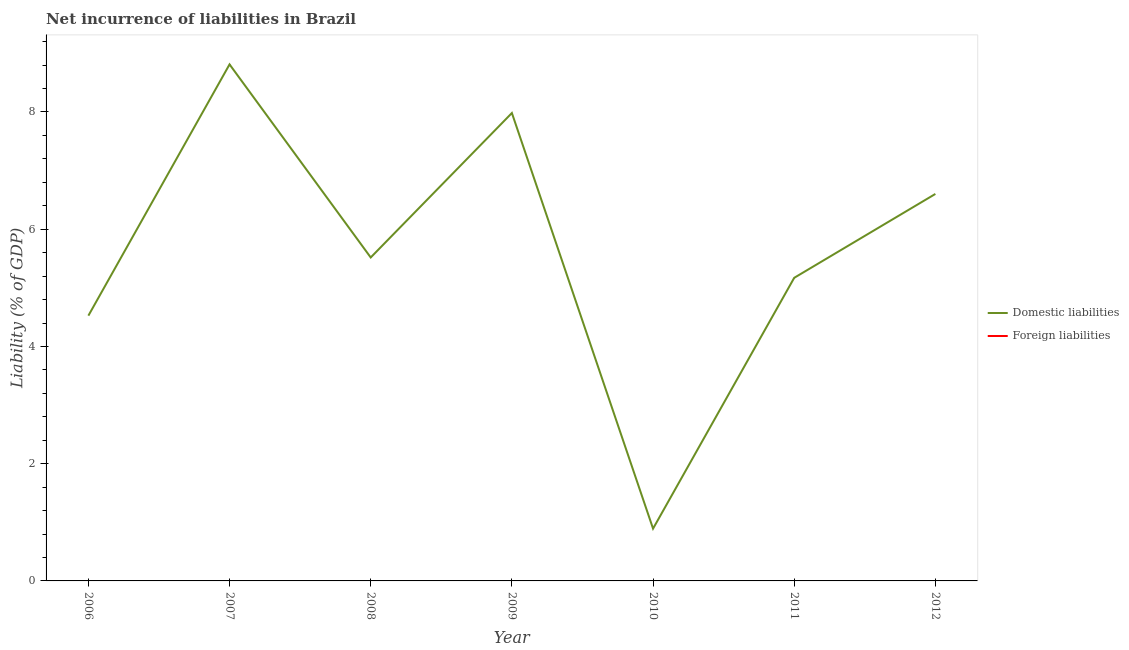How many different coloured lines are there?
Give a very brief answer. 1. Does the line corresponding to incurrence of foreign liabilities intersect with the line corresponding to incurrence of domestic liabilities?
Make the answer very short. No. Is the number of lines equal to the number of legend labels?
Ensure brevity in your answer.  No. Across all years, what is the maximum incurrence of domestic liabilities?
Provide a short and direct response. 8.81. Across all years, what is the minimum incurrence of domestic liabilities?
Offer a very short reply. 0.89. In which year was the incurrence of domestic liabilities maximum?
Give a very brief answer. 2007. What is the total incurrence of foreign liabilities in the graph?
Keep it short and to the point. 0. What is the difference between the incurrence of domestic liabilities in 2010 and that in 2012?
Keep it short and to the point. -5.71. What is the difference between the incurrence of domestic liabilities in 2011 and the incurrence of foreign liabilities in 2012?
Your answer should be very brief. 5.17. What is the ratio of the incurrence of domestic liabilities in 2009 to that in 2012?
Your answer should be very brief. 1.21. Is the incurrence of domestic liabilities in 2007 less than that in 2008?
Offer a terse response. No. What is the difference between the highest and the second highest incurrence of domestic liabilities?
Give a very brief answer. 0.83. What is the difference between the highest and the lowest incurrence of domestic liabilities?
Provide a succinct answer. 7.92. Does the incurrence of foreign liabilities monotonically increase over the years?
Keep it short and to the point. No. How many years are there in the graph?
Make the answer very short. 7. Are the values on the major ticks of Y-axis written in scientific E-notation?
Your response must be concise. No. Does the graph contain any zero values?
Keep it short and to the point. Yes. Does the graph contain grids?
Offer a terse response. No. How many legend labels are there?
Provide a succinct answer. 2. What is the title of the graph?
Give a very brief answer. Net incurrence of liabilities in Brazil. Does "Resident" appear as one of the legend labels in the graph?
Make the answer very short. No. What is the label or title of the X-axis?
Ensure brevity in your answer.  Year. What is the label or title of the Y-axis?
Provide a short and direct response. Liability (% of GDP). What is the Liability (% of GDP) of Domestic liabilities in 2006?
Give a very brief answer. 4.53. What is the Liability (% of GDP) of Domestic liabilities in 2007?
Your answer should be compact. 8.81. What is the Liability (% of GDP) of Foreign liabilities in 2007?
Ensure brevity in your answer.  0. What is the Liability (% of GDP) of Domestic liabilities in 2008?
Keep it short and to the point. 5.52. What is the Liability (% of GDP) in Domestic liabilities in 2009?
Provide a short and direct response. 7.98. What is the Liability (% of GDP) in Foreign liabilities in 2009?
Offer a terse response. 0. What is the Liability (% of GDP) of Domestic liabilities in 2010?
Your answer should be compact. 0.89. What is the Liability (% of GDP) in Foreign liabilities in 2010?
Keep it short and to the point. 0. What is the Liability (% of GDP) of Domestic liabilities in 2011?
Give a very brief answer. 5.17. What is the Liability (% of GDP) of Foreign liabilities in 2011?
Keep it short and to the point. 0. What is the Liability (% of GDP) of Domestic liabilities in 2012?
Ensure brevity in your answer.  6.6. What is the Liability (% of GDP) in Foreign liabilities in 2012?
Provide a succinct answer. 0. Across all years, what is the maximum Liability (% of GDP) in Domestic liabilities?
Your response must be concise. 8.81. Across all years, what is the minimum Liability (% of GDP) of Domestic liabilities?
Ensure brevity in your answer.  0.89. What is the total Liability (% of GDP) in Domestic liabilities in the graph?
Provide a succinct answer. 39.5. What is the difference between the Liability (% of GDP) of Domestic liabilities in 2006 and that in 2007?
Offer a very short reply. -4.29. What is the difference between the Liability (% of GDP) of Domestic liabilities in 2006 and that in 2008?
Provide a short and direct response. -0.99. What is the difference between the Liability (% of GDP) in Domestic liabilities in 2006 and that in 2009?
Your answer should be very brief. -3.46. What is the difference between the Liability (% of GDP) of Domestic liabilities in 2006 and that in 2010?
Provide a succinct answer. 3.63. What is the difference between the Liability (% of GDP) in Domestic liabilities in 2006 and that in 2011?
Give a very brief answer. -0.65. What is the difference between the Liability (% of GDP) in Domestic liabilities in 2006 and that in 2012?
Keep it short and to the point. -2.08. What is the difference between the Liability (% of GDP) in Domestic liabilities in 2007 and that in 2008?
Your response must be concise. 3.29. What is the difference between the Liability (% of GDP) of Domestic liabilities in 2007 and that in 2009?
Your answer should be compact. 0.83. What is the difference between the Liability (% of GDP) in Domestic liabilities in 2007 and that in 2010?
Your answer should be very brief. 7.92. What is the difference between the Liability (% of GDP) in Domestic liabilities in 2007 and that in 2011?
Give a very brief answer. 3.64. What is the difference between the Liability (% of GDP) of Domestic liabilities in 2007 and that in 2012?
Offer a terse response. 2.21. What is the difference between the Liability (% of GDP) of Domestic liabilities in 2008 and that in 2009?
Provide a short and direct response. -2.46. What is the difference between the Liability (% of GDP) in Domestic liabilities in 2008 and that in 2010?
Your answer should be very brief. 4.63. What is the difference between the Liability (% of GDP) in Domestic liabilities in 2008 and that in 2011?
Offer a very short reply. 0.35. What is the difference between the Liability (% of GDP) of Domestic liabilities in 2008 and that in 2012?
Provide a short and direct response. -1.08. What is the difference between the Liability (% of GDP) in Domestic liabilities in 2009 and that in 2010?
Keep it short and to the point. 7.09. What is the difference between the Liability (% of GDP) of Domestic liabilities in 2009 and that in 2011?
Your answer should be compact. 2.81. What is the difference between the Liability (% of GDP) of Domestic liabilities in 2009 and that in 2012?
Offer a very short reply. 1.38. What is the difference between the Liability (% of GDP) of Domestic liabilities in 2010 and that in 2011?
Offer a very short reply. -4.28. What is the difference between the Liability (% of GDP) in Domestic liabilities in 2010 and that in 2012?
Make the answer very short. -5.71. What is the difference between the Liability (% of GDP) of Domestic liabilities in 2011 and that in 2012?
Make the answer very short. -1.43. What is the average Liability (% of GDP) of Domestic liabilities per year?
Provide a succinct answer. 5.64. What is the ratio of the Liability (% of GDP) in Domestic liabilities in 2006 to that in 2007?
Give a very brief answer. 0.51. What is the ratio of the Liability (% of GDP) of Domestic liabilities in 2006 to that in 2008?
Keep it short and to the point. 0.82. What is the ratio of the Liability (% of GDP) in Domestic liabilities in 2006 to that in 2009?
Offer a terse response. 0.57. What is the ratio of the Liability (% of GDP) of Domestic liabilities in 2006 to that in 2010?
Your answer should be compact. 5.07. What is the ratio of the Liability (% of GDP) in Domestic liabilities in 2006 to that in 2011?
Your answer should be very brief. 0.88. What is the ratio of the Liability (% of GDP) of Domestic liabilities in 2006 to that in 2012?
Make the answer very short. 0.69. What is the ratio of the Liability (% of GDP) of Domestic liabilities in 2007 to that in 2008?
Give a very brief answer. 1.6. What is the ratio of the Liability (% of GDP) in Domestic liabilities in 2007 to that in 2009?
Your answer should be very brief. 1.1. What is the ratio of the Liability (% of GDP) of Domestic liabilities in 2007 to that in 2010?
Ensure brevity in your answer.  9.88. What is the ratio of the Liability (% of GDP) of Domestic liabilities in 2007 to that in 2011?
Provide a succinct answer. 1.7. What is the ratio of the Liability (% of GDP) of Domestic liabilities in 2007 to that in 2012?
Ensure brevity in your answer.  1.33. What is the ratio of the Liability (% of GDP) in Domestic liabilities in 2008 to that in 2009?
Your answer should be compact. 0.69. What is the ratio of the Liability (% of GDP) in Domestic liabilities in 2008 to that in 2010?
Provide a short and direct response. 6.19. What is the ratio of the Liability (% of GDP) in Domestic liabilities in 2008 to that in 2011?
Make the answer very short. 1.07. What is the ratio of the Liability (% of GDP) in Domestic liabilities in 2008 to that in 2012?
Provide a short and direct response. 0.84. What is the ratio of the Liability (% of GDP) in Domestic liabilities in 2009 to that in 2010?
Ensure brevity in your answer.  8.95. What is the ratio of the Liability (% of GDP) in Domestic liabilities in 2009 to that in 2011?
Your answer should be compact. 1.54. What is the ratio of the Liability (% of GDP) of Domestic liabilities in 2009 to that in 2012?
Your response must be concise. 1.21. What is the ratio of the Liability (% of GDP) of Domestic liabilities in 2010 to that in 2011?
Provide a succinct answer. 0.17. What is the ratio of the Liability (% of GDP) of Domestic liabilities in 2010 to that in 2012?
Give a very brief answer. 0.14. What is the ratio of the Liability (% of GDP) of Domestic liabilities in 2011 to that in 2012?
Keep it short and to the point. 0.78. What is the difference between the highest and the second highest Liability (% of GDP) in Domestic liabilities?
Offer a terse response. 0.83. What is the difference between the highest and the lowest Liability (% of GDP) in Domestic liabilities?
Your response must be concise. 7.92. 